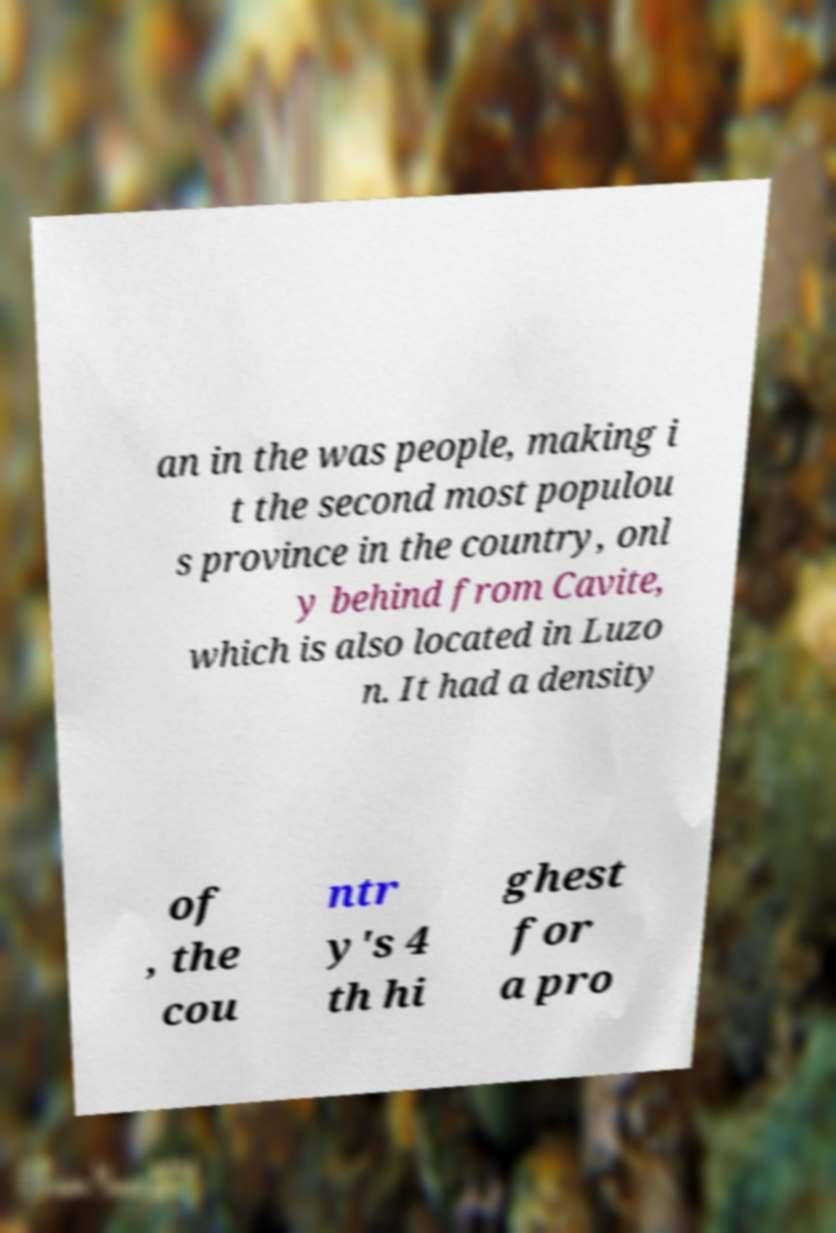Can you read and provide the text displayed in the image?This photo seems to have some interesting text. Can you extract and type it out for me? an in the was people, making i t the second most populou s province in the country, onl y behind from Cavite, which is also located in Luzo n. It had a density of , the cou ntr y's 4 th hi ghest for a pro 